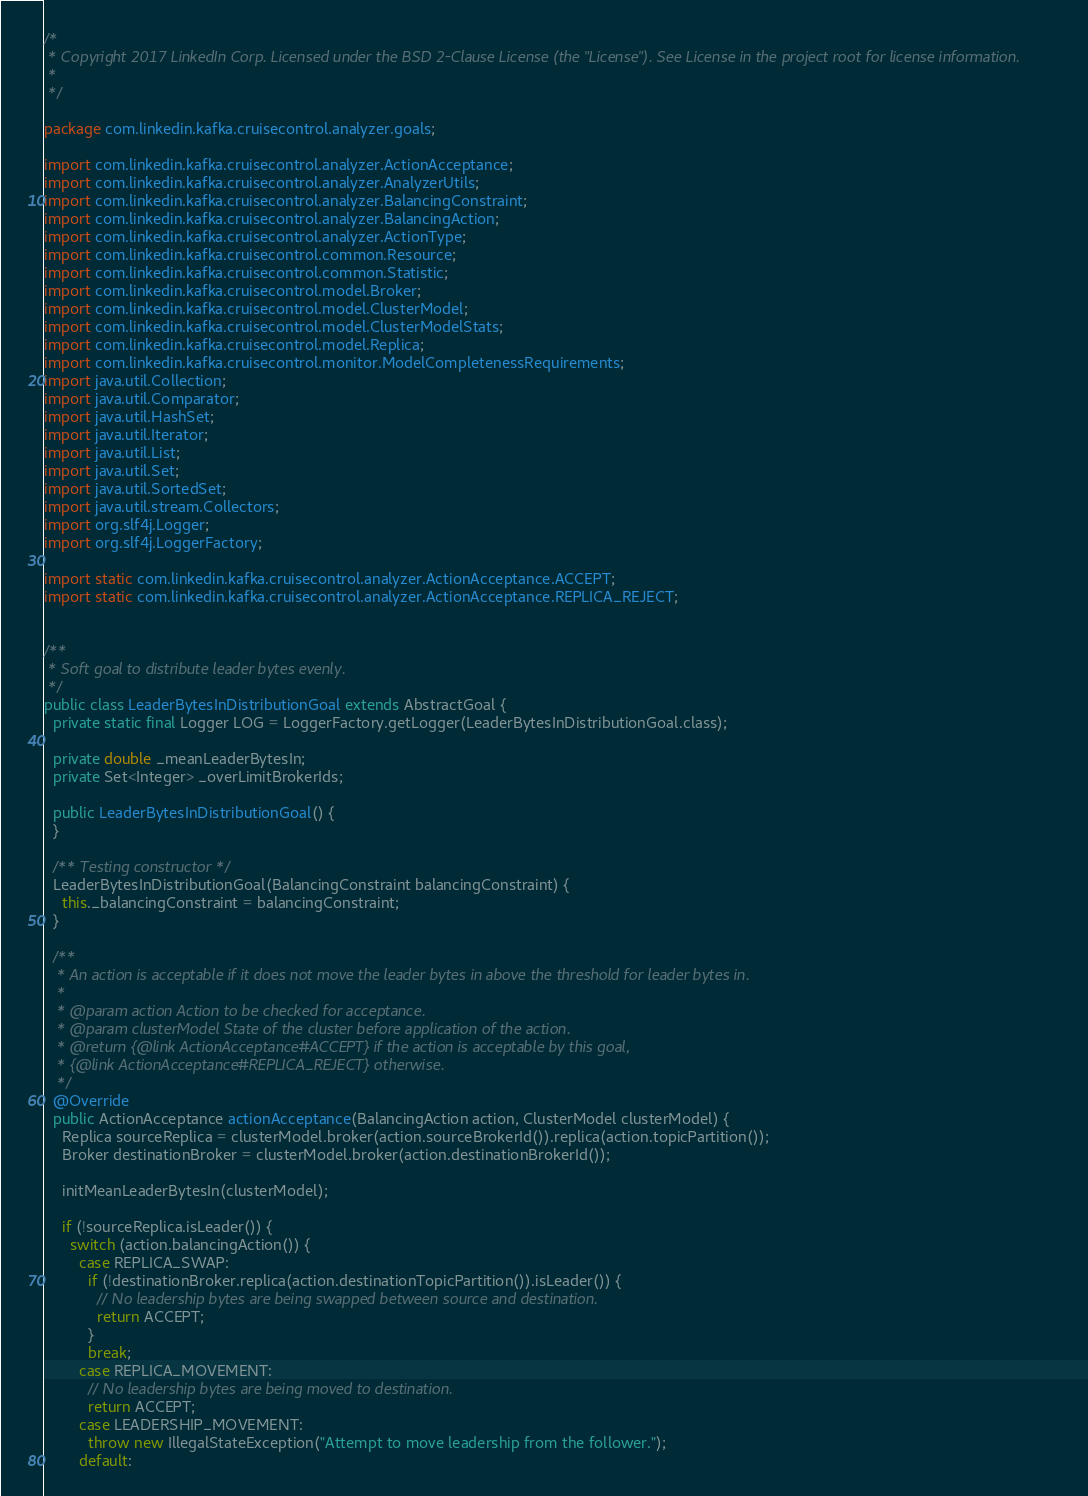<code> <loc_0><loc_0><loc_500><loc_500><_Java_>/*
 * Copyright 2017 LinkedIn Corp. Licensed under the BSD 2-Clause License (the "License"). See License in the project root for license information.
 *
 */

package com.linkedin.kafka.cruisecontrol.analyzer.goals;

import com.linkedin.kafka.cruisecontrol.analyzer.ActionAcceptance;
import com.linkedin.kafka.cruisecontrol.analyzer.AnalyzerUtils;
import com.linkedin.kafka.cruisecontrol.analyzer.BalancingConstraint;
import com.linkedin.kafka.cruisecontrol.analyzer.BalancingAction;
import com.linkedin.kafka.cruisecontrol.analyzer.ActionType;
import com.linkedin.kafka.cruisecontrol.common.Resource;
import com.linkedin.kafka.cruisecontrol.common.Statistic;
import com.linkedin.kafka.cruisecontrol.model.Broker;
import com.linkedin.kafka.cruisecontrol.model.ClusterModel;
import com.linkedin.kafka.cruisecontrol.model.ClusterModelStats;
import com.linkedin.kafka.cruisecontrol.model.Replica;
import com.linkedin.kafka.cruisecontrol.monitor.ModelCompletenessRequirements;
import java.util.Collection;
import java.util.Comparator;
import java.util.HashSet;
import java.util.Iterator;
import java.util.List;
import java.util.Set;
import java.util.SortedSet;
import java.util.stream.Collectors;
import org.slf4j.Logger;
import org.slf4j.LoggerFactory;

import static com.linkedin.kafka.cruisecontrol.analyzer.ActionAcceptance.ACCEPT;
import static com.linkedin.kafka.cruisecontrol.analyzer.ActionAcceptance.REPLICA_REJECT;


/**
 * Soft goal to distribute leader bytes evenly.
 */
public class LeaderBytesInDistributionGoal extends AbstractGoal {
  private static final Logger LOG = LoggerFactory.getLogger(LeaderBytesInDistributionGoal.class);

  private double _meanLeaderBytesIn;
  private Set<Integer> _overLimitBrokerIds;

  public LeaderBytesInDistributionGoal() {
  }

  /** Testing constructor */
  LeaderBytesInDistributionGoal(BalancingConstraint balancingConstraint) {
    this._balancingConstraint = balancingConstraint;
  }

  /**
   * An action is acceptable if it does not move the leader bytes in above the threshold for leader bytes in.
   *
   * @param action Action to be checked for acceptance.
   * @param clusterModel State of the cluster before application of the action.
   * @return {@link ActionAcceptance#ACCEPT} if the action is acceptable by this goal,
   * {@link ActionAcceptance#REPLICA_REJECT} otherwise.
   */
  @Override
  public ActionAcceptance actionAcceptance(BalancingAction action, ClusterModel clusterModel) {
    Replica sourceReplica = clusterModel.broker(action.sourceBrokerId()).replica(action.topicPartition());
    Broker destinationBroker = clusterModel.broker(action.destinationBrokerId());

    initMeanLeaderBytesIn(clusterModel);

    if (!sourceReplica.isLeader()) {
      switch (action.balancingAction()) {
        case REPLICA_SWAP:
          if (!destinationBroker.replica(action.destinationTopicPartition()).isLeader()) {
            // No leadership bytes are being swapped between source and destination.
            return ACCEPT;
          }
          break;
        case REPLICA_MOVEMENT:
          // No leadership bytes are being moved to destination.
          return ACCEPT;
        case LEADERSHIP_MOVEMENT:
          throw new IllegalStateException("Attempt to move leadership from the follower.");
        default:</code> 